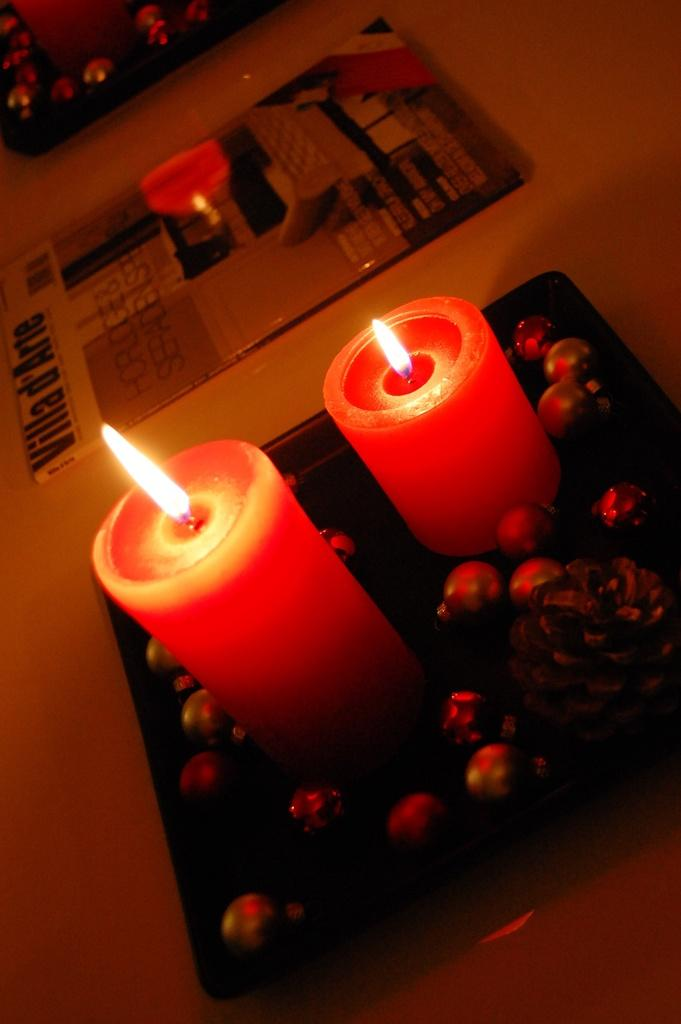What color are the candles in the image? The candles in the image are red. How many candles are present in the image? There are two candles in the image. Where are the candles located? The candles are in a black tray. What is the tray placed on? The tray is placed on a table top. What else can be seen near the tray? There is a book beside the tray. What type of underwear is the maid wearing in the image? There is no maid or underwear present in the image. Is the jail visible in the image? There is no jail present in the image. 